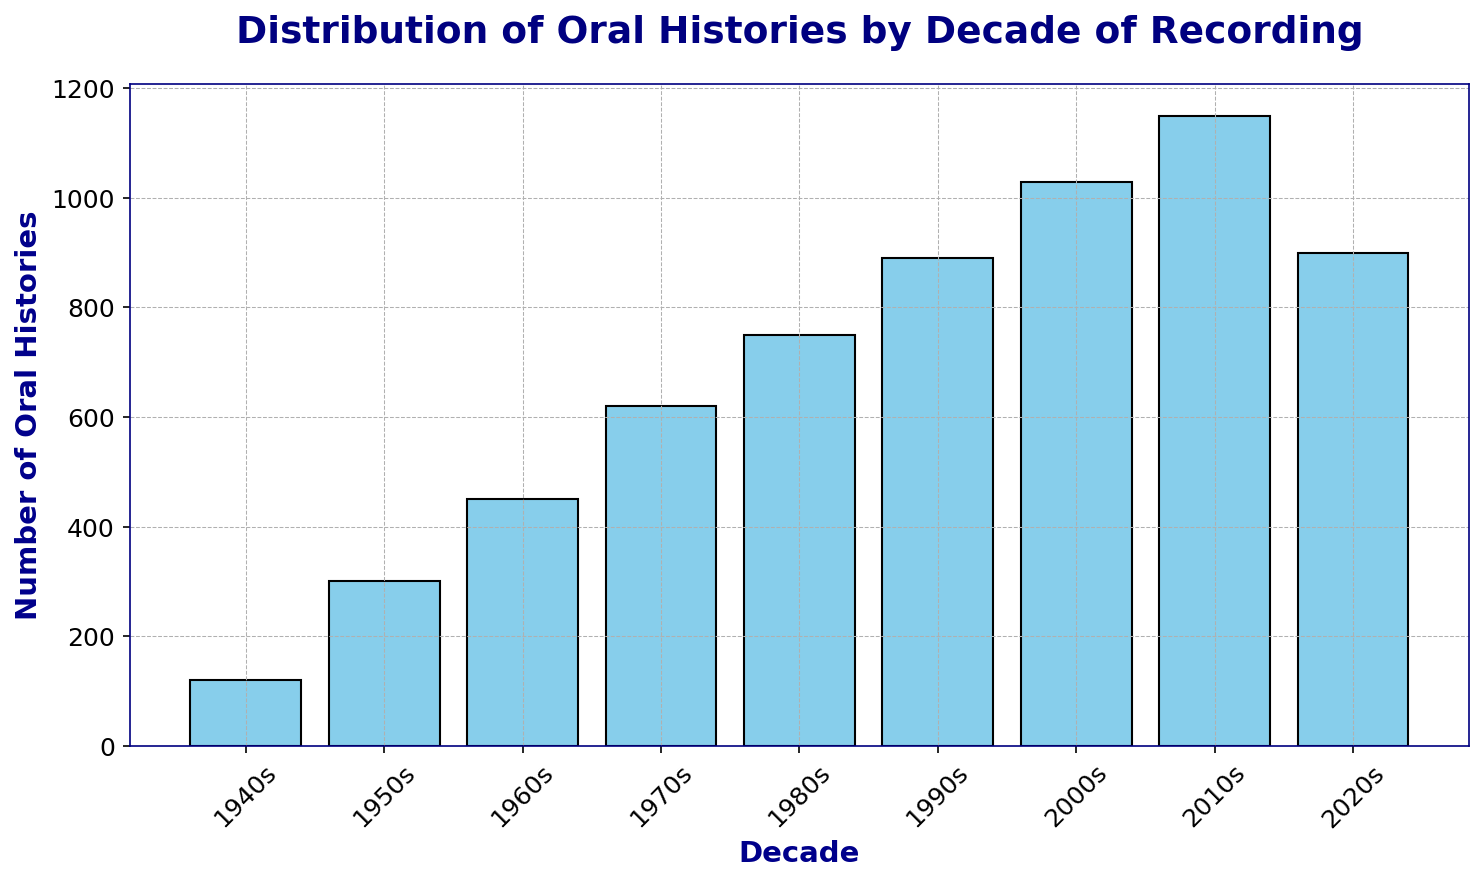What decade has the highest number of recorded oral histories? By looking at the height of the bars, we see the bar representing the 2010s is the tallest, indicating the highest number of recorded oral histories.
Answer: 2010s Which decade saw an increase in the number of oral histories recorded compared to the previous decade? Comparing the heights of successive bars, each decade from the 1940s to the 2010s shows an increase in the number of oral histories recorded.
Answer: Every decade until the 2010s What is the total number of recorded oral histories from the 1940s to the 1980s? Summing the values for each decade from the 1940s to the 1980s: 120 + 300 + 450 + 620 + 750 = 2240.
Answer: 2240 How does the number of oral histories recorded in the 2000s compare to the 2020s? The number of oral histories in the 2000s is 1030, and in the 2020s it is 900. Comparing these, the 2000s had more recorded oral histories than the 2020s.
Answer: The 2000s had more What is the average number of oral histories recorded per decade from the 1940s to the 2020s? Summing the values for all decades and dividing by the number of decades: (120 + 300 + 450 + 620 + 750 + 890 + 1030 + 1150 + 900) / 9 = 578.89.
Answer: 578.89 By how much did the number of oral histories increase from the 1960s to the 1970s? Subtracting the number of oral histories in the 1960s from the number in the 1970s: 620 - 450 = 170.
Answer: 170 Which decade saw the smallest number of recorded oral histories, and what is this number? The shortest bar in the chart represents the 1940s, with 120 recorded oral histories.
Answer: The 1940s, 120 During which decade did the number of oral histories first exceed 500? By looking at the increasing heights of the bars, the 1970s is the first decade where the number of recorded oral histories exceeds 500, as the number is 620.
Answer: 1970s What is the difference in the number of oral histories recorded between the decade with the highest number and the decade with the lowest number? Subtracting the number of oral histories in the 1940s from the number in the 2010s: 1150 - 120 = 1030.
Answer: 1030 